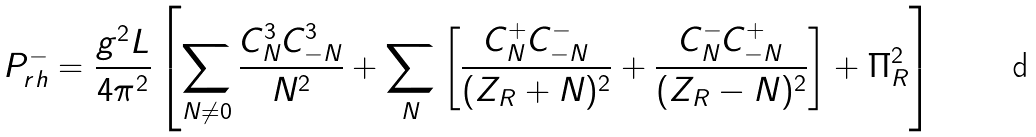<formula> <loc_0><loc_0><loc_500><loc_500>P _ { r h } ^ { - } = { \frac { g ^ { 2 } L } { 4 \pi ^ { 2 } } } \left [ \sum _ { N \neq 0 } { \frac { C _ { N } ^ { 3 } C _ { - N } ^ { 3 } } { N ^ { 2 } } } + \sum _ { N } \left [ { \frac { C _ { N } ^ { + } C _ { - N } ^ { - } } { ( Z _ { R } + N ) ^ { 2 } } } + { \frac { C _ { N } ^ { - } C _ { - N } ^ { + } } { ( Z _ { R } - N ) ^ { 2 } } } \right ] + \Pi _ { R } ^ { 2 } \right ]</formula> 